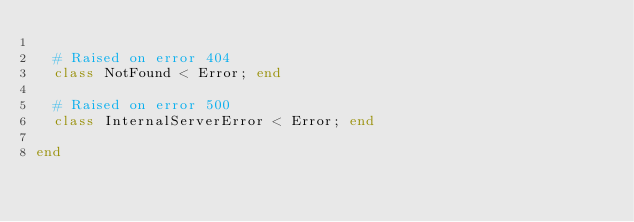Convert code to text. <code><loc_0><loc_0><loc_500><loc_500><_Ruby_>
  # Raised on error 404
  class NotFound < Error; end

  # Raised on error 500
  class InternalServerError < Error; end

end</code> 